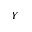Convert formula to latex. <formula><loc_0><loc_0><loc_500><loc_500>Y</formula> 